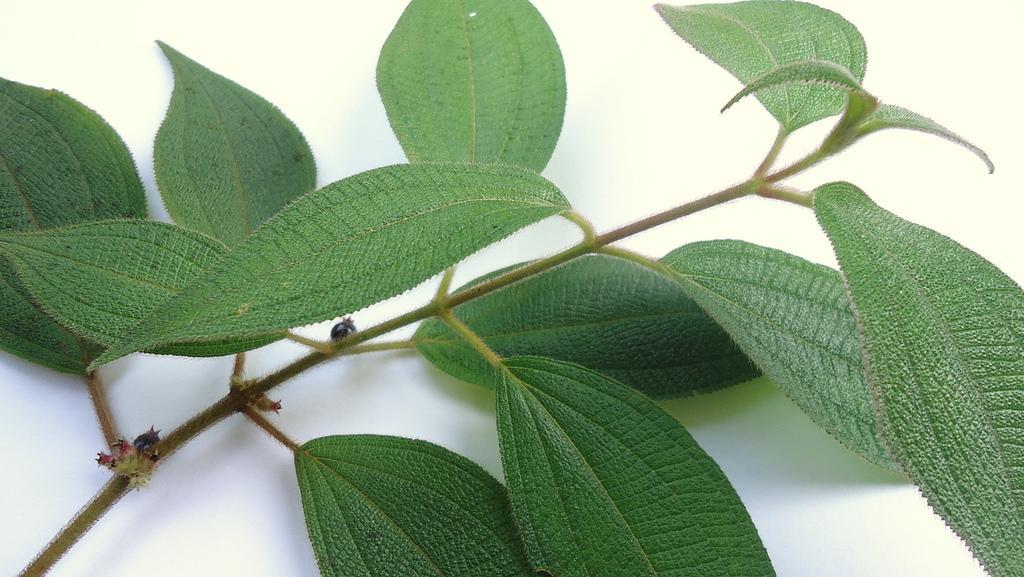Can you describe this image briefly? Here we can see stem with leaves. 